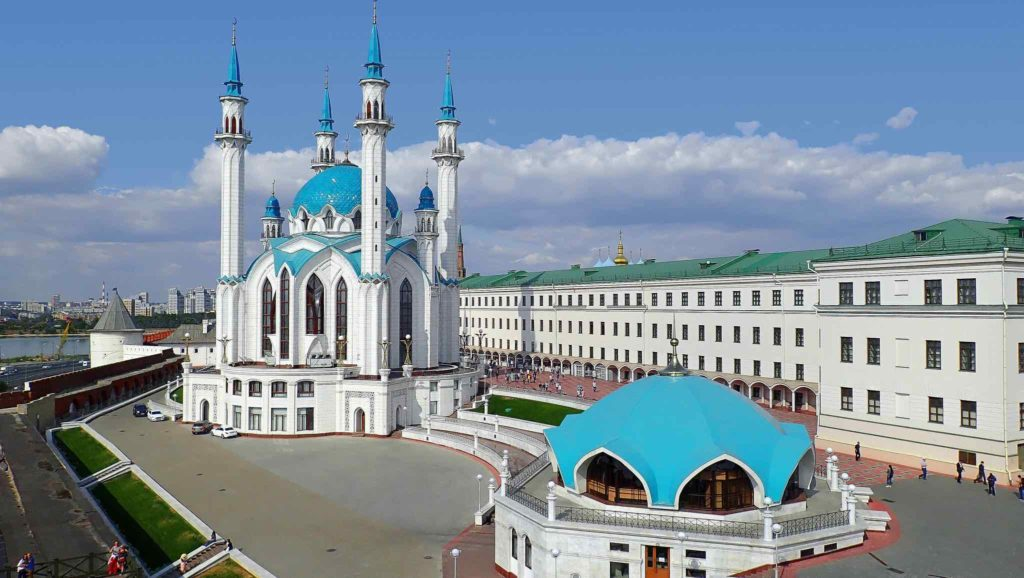Can you tell me more about the architectural style of the Kul Sharif Mosque? The Kul Sharif Mosque showcases a remarkable blend of Islamic architecture with Tatar influences, characterized by its bright blue domes and white façade. The structure is modern, completed in 2005, yet it pays homage to the history of the region. The design incorporates eight minarets, symbolizing the eight gates of Paradise as described in Islam. The mosque's large windows allow natural light to flood the interiors, highlighting intricate Islamic calligraphy and decorations that adorn the walls and ceiling. 